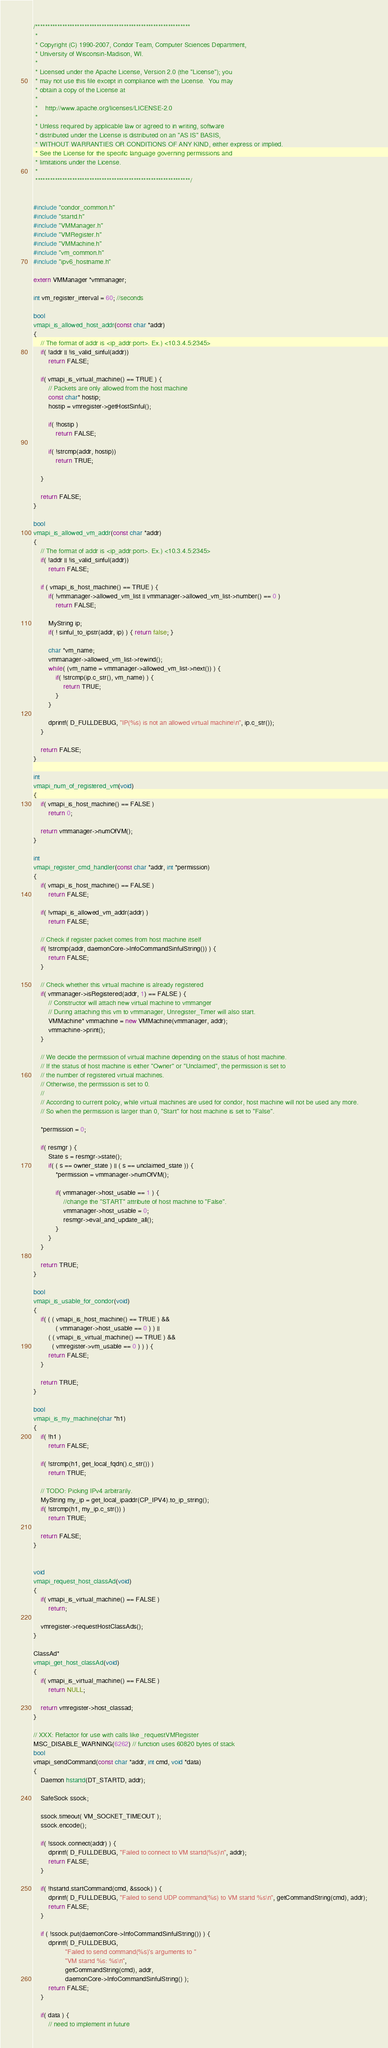<code> <loc_0><loc_0><loc_500><loc_500><_C++_>/***************************************************************
 *
 * Copyright (C) 1990-2007, Condor Team, Computer Sciences Department,
 * University of Wisconsin-Madison, WI.
 * 
 * Licensed under the Apache License, Version 2.0 (the "License"); you
 * may not use this file except in compliance with the License.  You may
 * obtain a copy of the License at
 * 
 *    http://www.apache.org/licenses/LICENSE-2.0
 * 
 * Unless required by applicable law or agreed to in writing, software
 * distributed under the License is distributed on an "AS IS" BASIS,
 * WITHOUT WARRANTIES OR CONDITIONS OF ANY KIND, either express or implied.
 * See the License for the specific language governing permissions and
 * limitations under the License.
 *
 ***************************************************************/


#include "condor_common.h"
#include "startd.h"
#include "VMManager.h"
#include "VMRegister.h"
#include "VMMachine.h"
#include "vm_common.h"
#include "ipv6_hostname.h"

extern VMManager *vmmanager;

int vm_register_interval = 60; //seconds

bool 
vmapi_is_allowed_host_addr(const char *addr)
{
	// The format of addr is <ip_addr:port>. Ex.) <10.3.4.5:2345>
	if( !addr || !is_valid_sinful(addr))
		return FALSE;

	if( vmapi_is_virtual_machine() == TRUE ) {
		// Packets are only allowed from the host machine
		const char* hostip;
		hostip = vmregister->getHostSinful();

		if( !hostip )
			return FALSE;

		if( !strcmp(addr, hostip))
			return TRUE;

	}

	return FALSE;
}

bool 
vmapi_is_allowed_vm_addr(const char *addr)
{
	// The format of addr is <ip_addr:port>. Ex.) <10.3.4.5:2345>
	if( !addr || !is_valid_sinful(addr))
		return FALSE;

	if ( vmapi_is_host_machine() == TRUE ) {
		if( !vmmanager->allowed_vm_list || vmmanager->allowed_vm_list->number() == 0 )
			return FALSE;

		MyString ip;
		if( ! sinful_to_ipstr(addr, ip) ) { return false; }

		char *vm_name;
		vmmanager->allowed_vm_list->rewind();
		while( (vm_name = vmmanager->allowed_vm_list->next()) ) {
			if( !strcmp(ip.c_str(), vm_name) ) {
				return TRUE;
			}
		}

		dprintf( D_FULLDEBUG, "IP(%s) is not an allowed virtual machine\n", ip.c_str());
	}

	return FALSE;
}

int 
vmapi_num_of_registered_vm(void)
{
	if( vmapi_is_host_machine() == FALSE )
		return 0;

	return vmmanager->numOfVM();
}

int 
vmapi_register_cmd_handler(const char *addr, int *permission)
{
	if( vmapi_is_host_machine() == FALSE )
		return FALSE;

	if( !vmapi_is_allowed_vm_addr(addr) )
		return FALSE;

	// Check if register packet comes from host machine itself
	if( !strcmp(addr, daemonCore->InfoCommandSinfulString()) ) {
		return FALSE;
	}

	// Check whether this virtual machine is already registered
	if( vmmanager->isRegistered(addr, 1) == FALSE ) {
		// Constructor will attach new virtual machine to vmmanger 
		// During attaching this vm to vmmanager, Unregister_Timer will also start.
		VMMachine* vmmachine = new VMMachine(vmmanager, addr);
		vmmachine->print();
	}

	// We decide the permission of virtual machine depending on the status of host machine.
	// If the status of host machine is either "Owner" or "Unclaimed", the permission is set to 
	// the number of registered virtual machines. 
	// Otherwise, the permission is set to 0.
	//
	// According to current policy, while virtual machines are used for condor, host machine will not be used any more.
	// So when the permission is larger than 0, "Start" for host machine is set to "False".
	
	*permission = 0;

	if( resmgr ) {
		State s = resmgr->state();
		if( ( s == owner_state ) || ( s == unclaimed_state )) {
			*permission = vmmanager->numOfVM();

			if( vmmanager->host_usable == 1 ) {
				//change the "START" attribute of host machine to "False".
				vmmanager->host_usable = 0;
				resmgr->eval_and_update_all();
			}
		}
	}

	return TRUE;
}

bool 
vmapi_is_usable_for_condor(void)
{
	if( ( ( vmapi_is_host_machine() == TRUE ) && 
			( vmmanager->host_usable == 0 ) ) || 
		( ( vmapi_is_virtual_machine() == TRUE ) && 
		  ( vmregister->vm_usable == 0 ) ) ) {
		return FALSE;
	}

	return TRUE;
}

bool 
vmapi_is_my_machine(char *h1)
{
	if( !h1 )
		return FALSE;

	if( !strcmp(h1, get_local_fqdn().c_str()) )
		return TRUE;

	// TODO: Picking IPv4 arbitrarily.
	MyString my_ip = get_local_ipaddr(CP_IPV4).to_ip_string();
	if( !strcmp(h1, my_ip.c_str()) )
		return TRUE;

	return FALSE;
}


void
vmapi_request_host_classAd(void)
{
	if( vmapi_is_virtual_machine() == FALSE )
		return;

	vmregister->requestHostClassAds();
}

ClassAd* 
vmapi_get_host_classAd(void)
{
	if( vmapi_is_virtual_machine() == FALSE )
		return NULL;

	return vmregister->host_classad;
}

// XXX: Refactor for use with calls like _requestVMRegister
MSC_DISABLE_WARNING(6262) // function uses 60820 bytes of stack
bool 
vmapi_sendCommand(const char *addr, int cmd, void *data)
{
	Daemon hstartd(DT_STARTD, addr);

	SafeSock ssock;

	ssock.timeout( VM_SOCKET_TIMEOUT );
	ssock.encode();
	
	if( !ssock.connect(addr) ) {
		dprintf( D_FULLDEBUG, "Failed to connect to VM startd(%s)\n", addr);
		return FALSE;
	}

	if( !hstartd.startCommand(cmd, &ssock) ) { 
		dprintf( D_FULLDEBUG, "Failed to send UDP command(%s) to VM startd %s\n", getCommandString(cmd), addr);
		return FALSE;
	}

	if ( !ssock.put(daemonCore->InfoCommandSinfulString()) ) {
		dprintf( D_FULLDEBUG,
				 "Failed to send command(%s)'s arguments to "
				 "VM startd %s: %s\n",
				 getCommandString(cmd), addr,
				 daemonCore->InfoCommandSinfulString() );
		return FALSE;
	}

	if( data ) {
		// need to implement in future</code> 